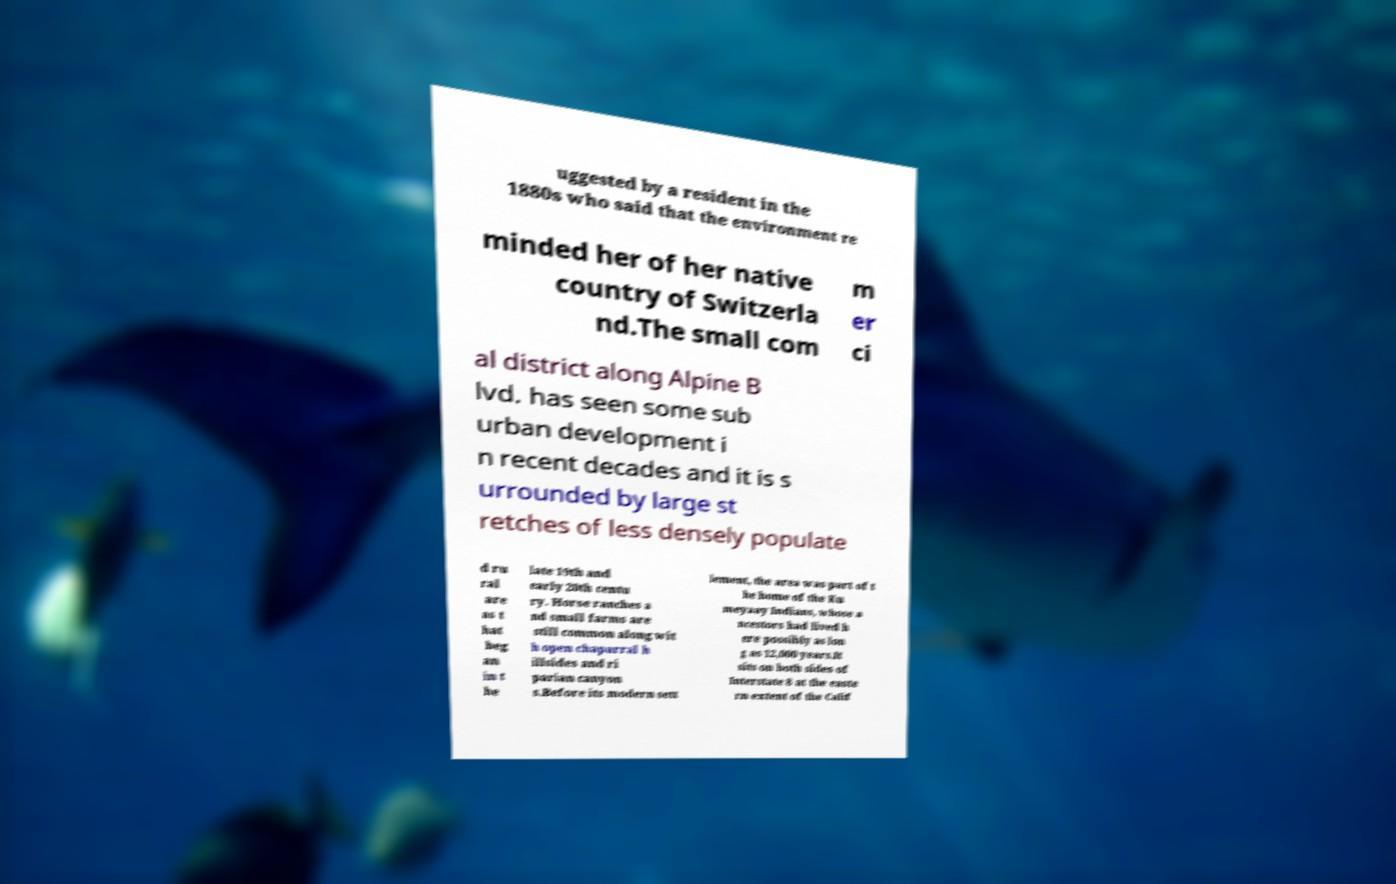Please read and relay the text visible in this image. What does it say? uggested by a resident in the 1880s who said that the environment re minded her of her native country of Switzerla nd.The small com m er ci al district along Alpine B lvd. has seen some sub urban development i n recent decades and it is s urrounded by large st retches of less densely populate d ru ral are as t hat beg an in t he late 19th and early 20th centu ry. Horse ranches a nd small farms are still common along wit h open chaparral h illsides and ri parian canyon s.Before its modern sett lement, the area was part of t he home of the Ku meyaay Indians, whose a ncestors had lived h ere possibly as lon g as 12,000 years.It sits on both sides of Interstate 8 at the easte rn extent of the Calif 